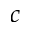<formula> <loc_0><loc_0><loc_500><loc_500>c</formula> 